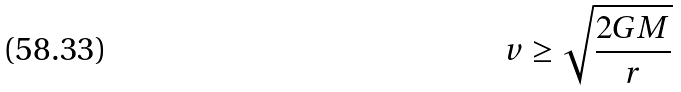Convert formula to latex. <formula><loc_0><loc_0><loc_500><loc_500>v \geq \sqrt { \frac { 2 G M } { r } }</formula> 